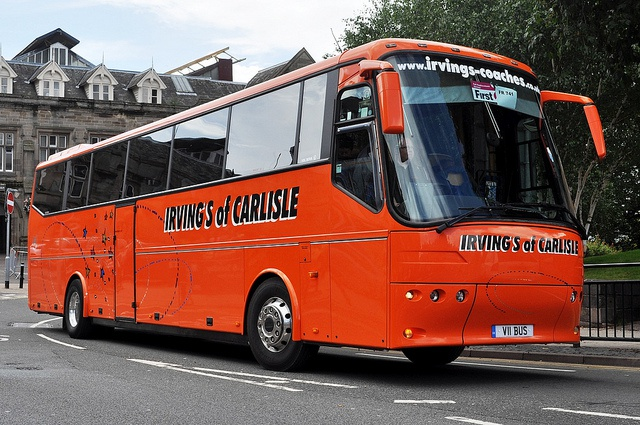Describe the objects in this image and their specific colors. I can see bus in lavender, black, red, and gray tones, people in lavender, black, darkgray, and gray tones, and people in lavender, black, teal, and gray tones in this image. 